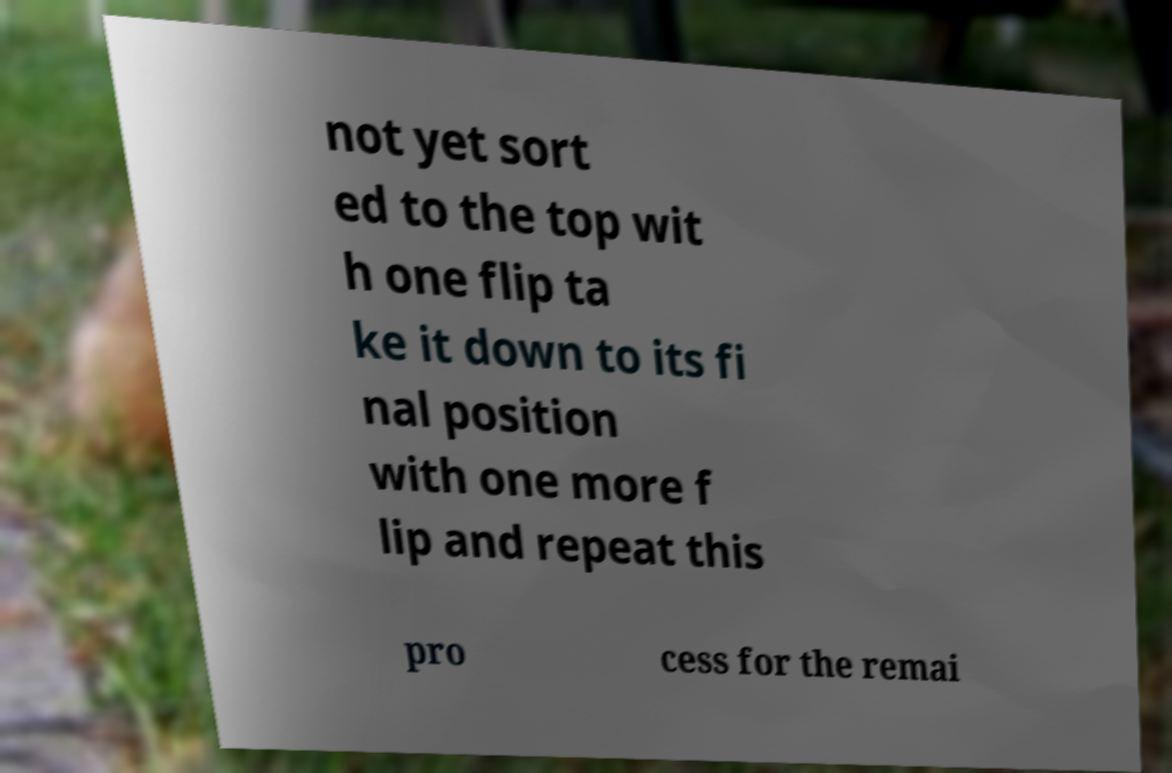What messages or text are displayed in this image? I need them in a readable, typed format. not yet sort ed to the top wit h one flip ta ke it down to its fi nal position with one more f lip and repeat this pro cess for the remai 